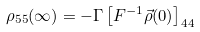<formula> <loc_0><loc_0><loc_500><loc_500>\rho _ { 5 5 } ( \infty ) = - \Gamma \left [ F ^ { - 1 } \vec { \rho } ( 0 ) \right ] _ { 4 4 }</formula> 